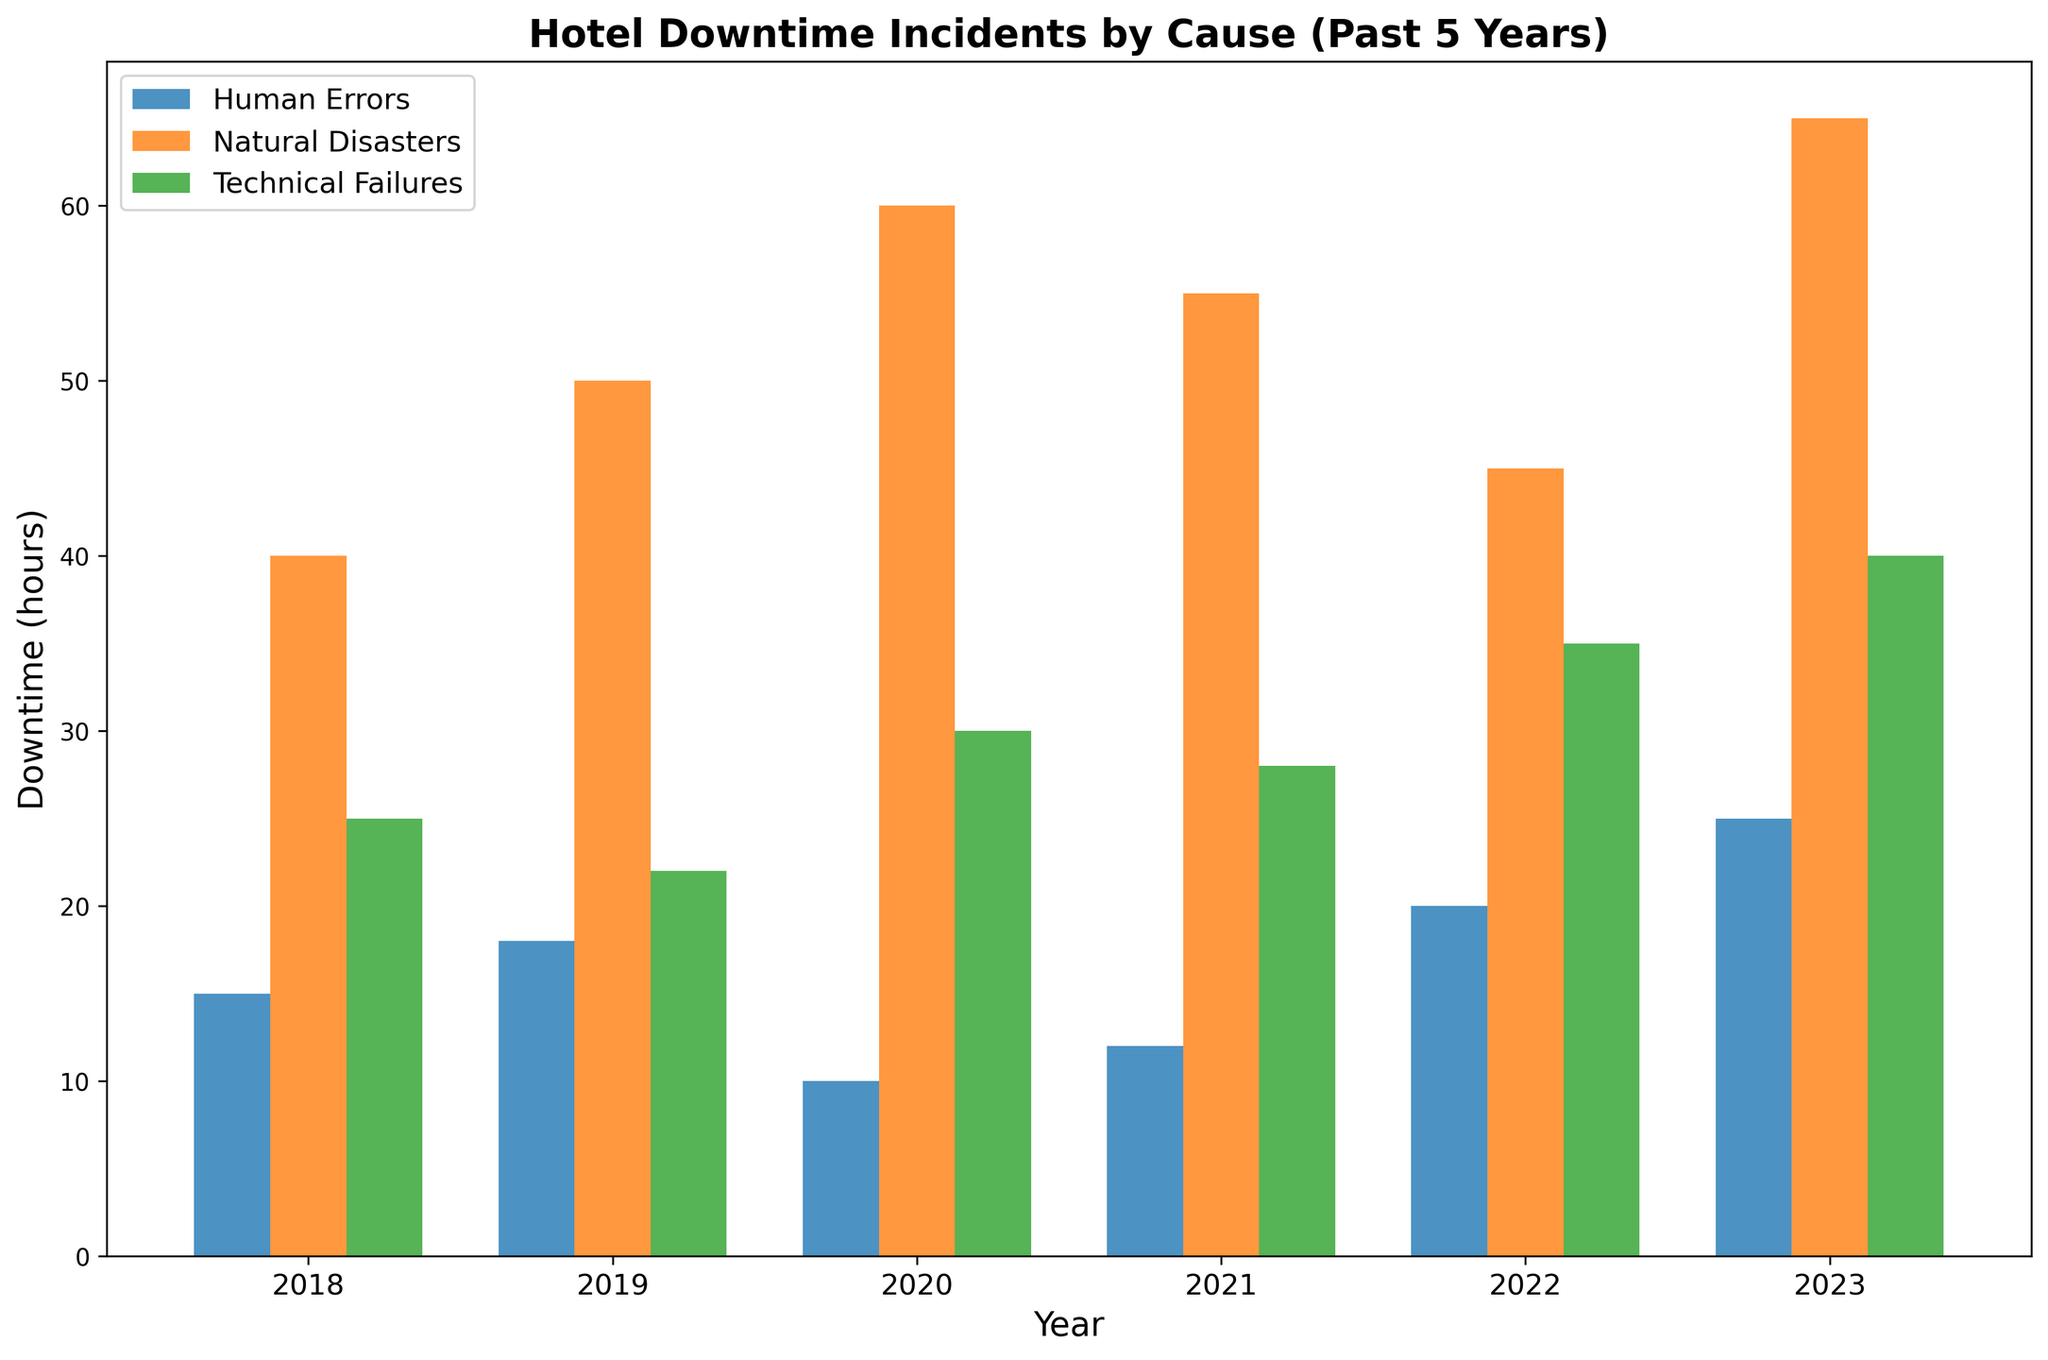What was the total downtime in 2019 across all causes? To find the total downtime in 2019, add the downtime for each cause: 50 hours (Natural Disasters) + 22 hours (Technical Failures) + 18 hours (Human Errors) = 90 hours
Answer: 90 hours Which year had the highest total downtime due to human errors? Look at the human errors bars across all years and compare their heights. The highest bar is in 2023 with 25 hours
Answer: 2023 Did the downtime due to technical failures increase, decrease, or stay the same from 2021 to 2022? Compare the height of the bars for technical failures in 2021 and 2022: 28 hours in 2021 and 35 hours in 2022. This shows an increase
Answer: Increase What is the difference in downtime due to natural disasters between 2020 and 2022? The downtime due to natural disasters in 2020 is 60 hours and in 2022 is 45 hours. The difference is 60 - 45 = 15 hours
Answer: 15 hours How much total downtime was recorded in the year 2020? Sum the downtime across all causes for 2020: 60 hours (Natural Disasters) + 30 hours (Technical Failures) + 10 hours (Human Errors) = 100 hours
Answer: 100 hours Which cause had the most significant increase in downtime from 2018 to 2019? Compare the differences for each cause: Natural Disasters increased by 10 hours (50 - 40), Technical Failures decreased by 3 hours (22 - 25), and Human Errors increased by 3 hours (18 - 15). The most significant increase is Natural Disasters
Answer: Natural Disasters In which year did technical failures cause the most downtime? Compare the height of the technical failures bars across all years. The highest bar is in 2023 with 40 hours
Answer: 2023 Which cause had consistently increasing downtime from 2018 to 2023? Observe the trends for each cause. Technical Failures show a consistent increase over these years: 25, 22, 30, 28, 35, 40
Answer: Technical Failures What is the average yearly downtime due to natural disasters over the past 5 years? Sum the downtime due to natural disasters over the past 5 years: 40 + 50 + 60 + 55 + 45 + 65 = 315 hours. Then divide by 6 years: 315 / 6 = 52.5 hours
Answer: 52.5 hours Compare the downtime due to human errors and technical failures in 2023. Which was higher and by how much? In 2023, human errors caused 25 hours of downtime, and technical failures caused 40 hours. Difference: 40 - 25 = 15 hours. Technical Failures had a higher downtime
Answer: Technical Failures by 15 hours 